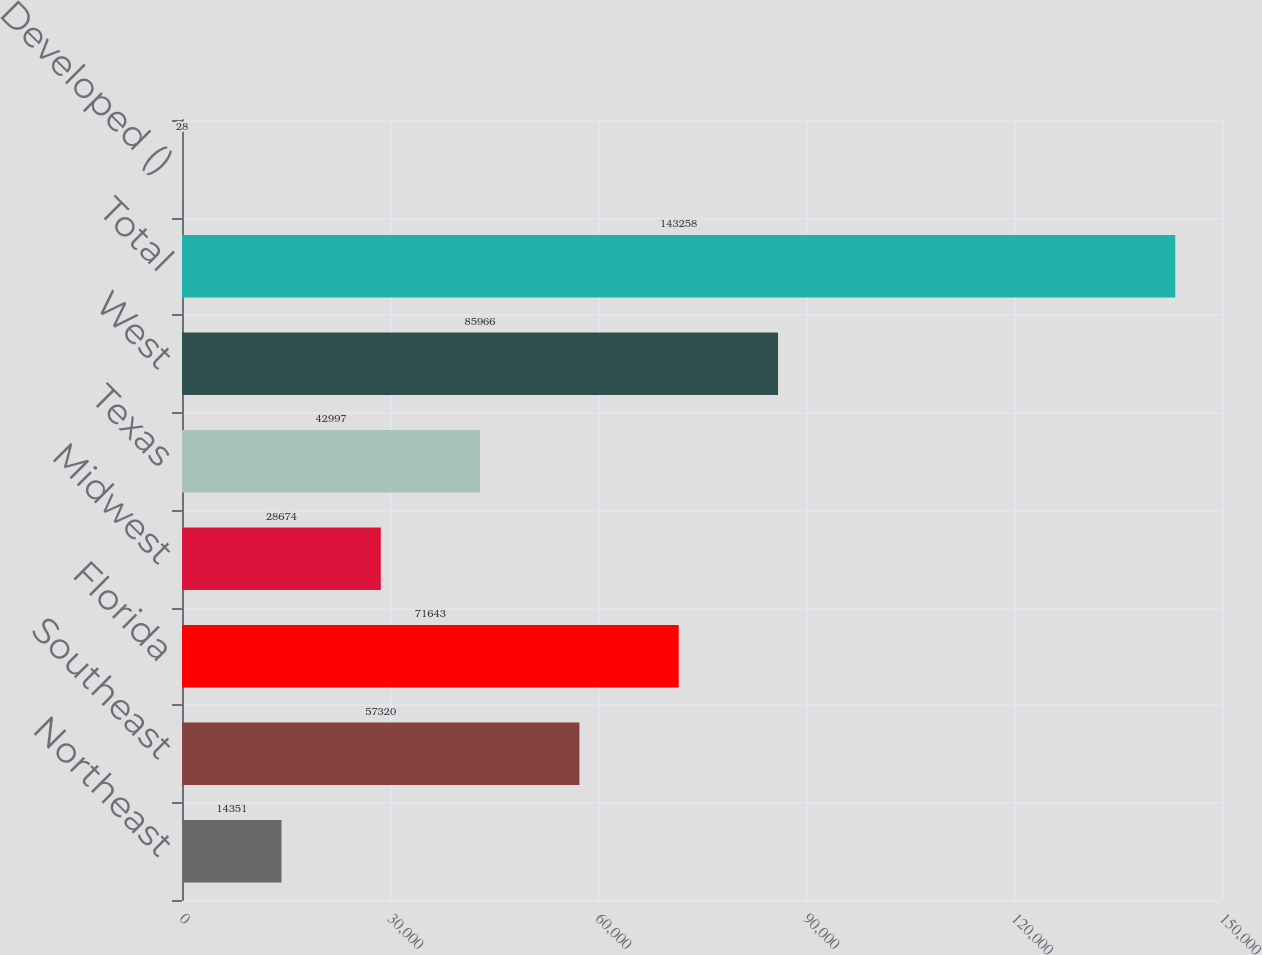Convert chart to OTSL. <chart><loc_0><loc_0><loc_500><loc_500><bar_chart><fcel>Northeast<fcel>Southeast<fcel>Florida<fcel>Midwest<fcel>Texas<fcel>West<fcel>Total<fcel>Developed ()<nl><fcel>14351<fcel>57320<fcel>71643<fcel>28674<fcel>42997<fcel>85966<fcel>143258<fcel>28<nl></chart> 